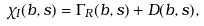<formula> <loc_0><loc_0><loc_500><loc_500>\chi _ { I } ( b , s ) = \Gamma _ { R } ( b , s ) + D ( b , s ) ,</formula> 